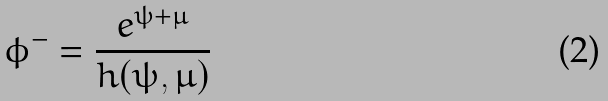Convert formula to latex. <formula><loc_0><loc_0><loc_500><loc_500>\phi ^ { - } = \frac { e ^ { \psi + \mu } } { h ( \psi , \mu ) }</formula> 